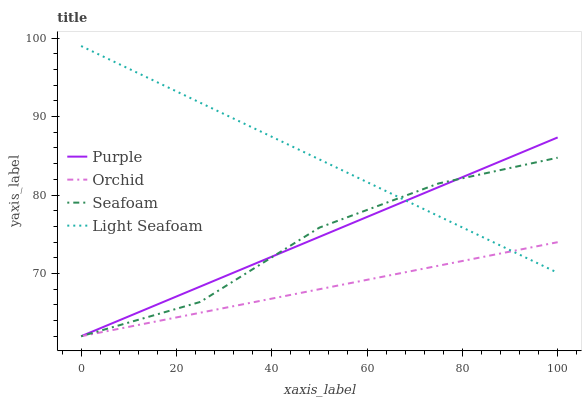Does Orchid have the minimum area under the curve?
Answer yes or no. Yes. Does Light Seafoam have the maximum area under the curve?
Answer yes or no. Yes. Does Seafoam have the minimum area under the curve?
Answer yes or no. No. Does Seafoam have the maximum area under the curve?
Answer yes or no. No. Is Light Seafoam the smoothest?
Answer yes or no. Yes. Is Seafoam the roughest?
Answer yes or no. Yes. Is Seafoam the smoothest?
Answer yes or no. No. Is Light Seafoam the roughest?
Answer yes or no. No. Does Light Seafoam have the lowest value?
Answer yes or no. No. Does Light Seafoam have the highest value?
Answer yes or no. Yes. Does Seafoam have the highest value?
Answer yes or no. No. Does Orchid intersect Light Seafoam?
Answer yes or no. Yes. Is Orchid less than Light Seafoam?
Answer yes or no. No. Is Orchid greater than Light Seafoam?
Answer yes or no. No. 